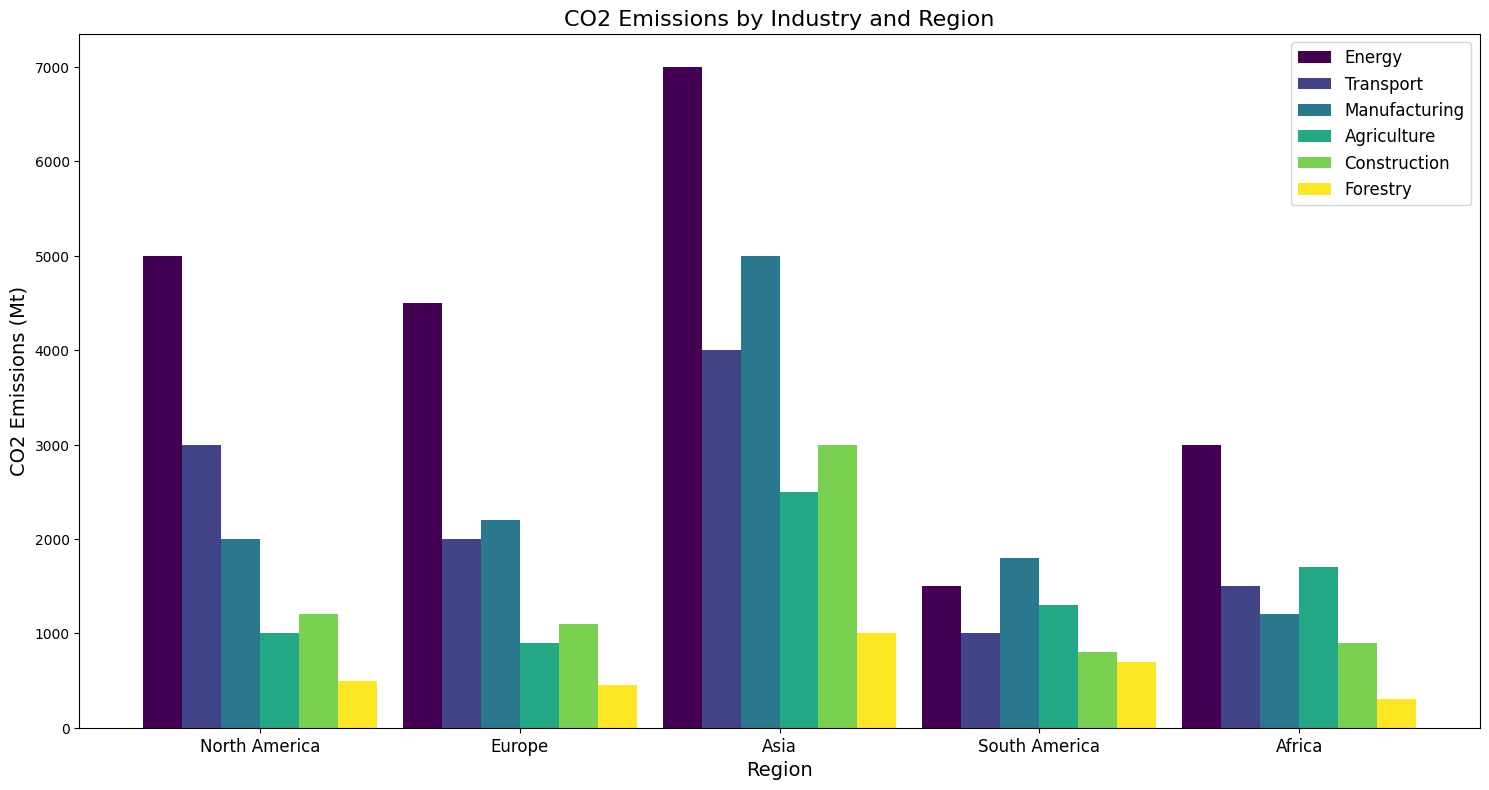Which industry has the highest CO2 emissions in the Asia region? Look at the bar heights for each industry within the Asia region. The tallest bar represents the highest emissions. The tallest bar for Asia belongs to the Energy industry.
Answer: Energy Which region has the lowest CO2 emissions in the Transport industry? Observe the bar heights for the Transport industry across all regions. The shortest bar represents the lowest emissions. In the Transport industry, Africa has the shortest bar.
Answer: Africa What is the total CO2 emissions for the Manufacturing industry across all regions? Add the CO2 emissions from the Manufacturing industry for all regions: 2000 (North America) + 2200 (Europe) + 5000 (Asia) + 1800 (South America) + 1200 (Africa). This sums up to 12200 Mt.
Answer: 12200 Mt Compare the CO2 emissions in the Agriculture industry between North America and Asia. Which one is higher and by how much? The bar for North America in Agriculture industry shows 1000 Mt, and for Asia, it is 2500 Mt. The difference is 2500 - 1000 = 1500 Mt, with Asia being higher.
Answer: Asia, 1500 Mt What is the average CO2 emission of the Energy industry across all regions? Sum the CO2 emissions from the Energy industry: 5000 (North America) + 4500 (Europe) + 7000 (Asia) + 1500 (South America) + 3000 (Africa). The sum is 21000 Mt. Divide by the number of regions (5): 21000 / 5 = 4200 Mt.
Answer: 4200 Mt 